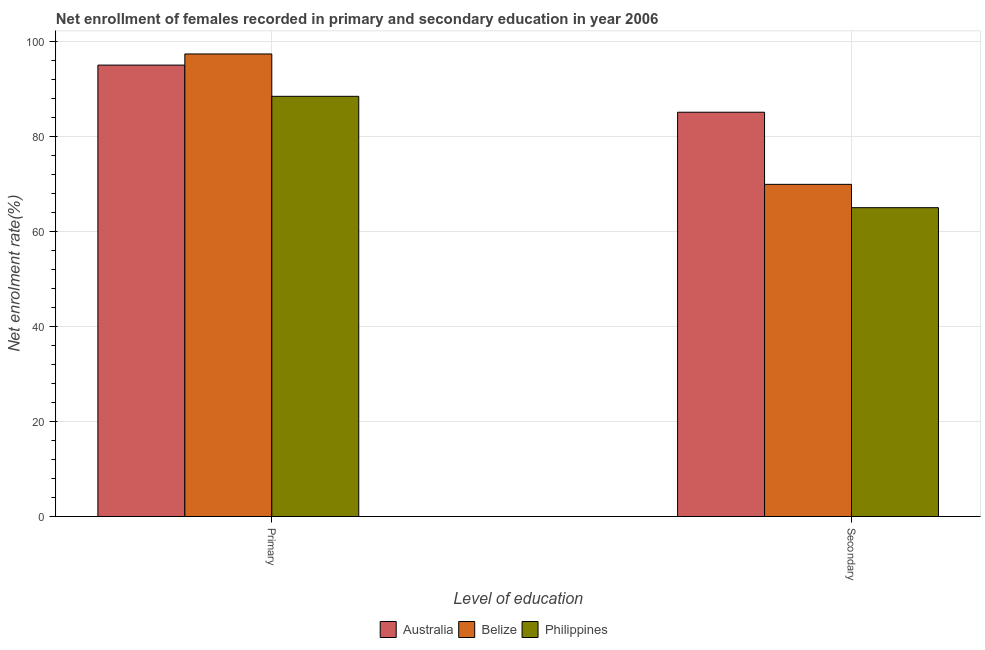How many different coloured bars are there?
Offer a terse response. 3. How many bars are there on the 1st tick from the right?
Provide a succinct answer. 3. What is the label of the 1st group of bars from the left?
Ensure brevity in your answer.  Primary. What is the enrollment rate in secondary education in Australia?
Keep it short and to the point. 85.03. Across all countries, what is the maximum enrollment rate in primary education?
Offer a terse response. 97.29. Across all countries, what is the minimum enrollment rate in primary education?
Offer a very short reply. 88.38. In which country was the enrollment rate in secondary education maximum?
Offer a very short reply. Australia. What is the total enrollment rate in secondary education in the graph?
Ensure brevity in your answer.  219.86. What is the difference between the enrollment rate in primary education in Australia and that in Philippines?
Your response must be concise. 6.57. What is the difference between the enrollment rate in primary education in Australia and the enrollment rate in secondary education in Philippines?
Ensure brevity in your answer.  29.99. What is the average enrollment rate in secondary education per country?
Make the answer very short. 73.29. What is the difference between the enrollment rate in secondary education and enrollment rate in primary education in Belize?
Offer a very short reply. -27.43. In how many countries, is the enrollment rate in secondary education greater than 28 %?
Your response must be concise. 3. What is the ratio of the enrollment rate in primary education in Philippines to that in Australia?
Offer a terse response. 0.93. Is the enrollment rate in primary education in Belize less than that in Australia?
Provide a succinct answer. No. In how many countries, is the enrollment rate in primary education greater than the average enrollment rate in primary education taken over all countries?
Your answer should be very brief. 2. What does the 2nd bar from the left in Primary represents?
Provide a succinct answer. Belize. How many bars are there?
Keep it short and to the point. 6. Are the values on the major ticks of Y-axis written in scientific E-notation?
Keep it short and to the point. No. Does the graph contain grids?
Provide a succinct answer. Yes. How many legend labels are there?
Ensure brevity in your answer.  3. How are the legend labels stacked?
Provide a short and direct response. Horizontal. What is the title of the graph?
Make the answer very short. Net enrollment of females recorded in primary and secondary education in year 2006. What is the label or title of the X-axis?
Your answer should be very brief. Level of education. What is the label or title of the Y-axis?
Make the answer very short. Net enrolment rate(%). What is the Net enrolment rate(%) in Australia in Primary?
Your answer should be very brief. 94.95. What is the Net enrolment rate(%) of Belize in Primary?
Provide a short and direct response. 97.29. What is the Net enrolment rate(%) in Philippines in Primary?
Offer a very short reply. 88.38. What is the Net enrolment rate(%) in Australia in Secondary?
Provide a succinct answer. 85.03. What is the Net enrolment rate(%) of Belize in Secondary?
Your answer should be compact. 69.87. What is the Net enrolment rate(%) of Philippines in Secondary?
Give a very brief answer. 64.96. Across all Level of education, what is the maximum Net enrolment rate(%) in Australia?
Your response must be concise. 94.95. Across all Level of education, what is the maximum Net enrolment rate(%) of Belize?
Your answer should be very brief. 97.29. Across all Level of education, what is the maximum Net enrolment rate(%) in Philippines?
Make the answer very short. 88.38. Across all Level of education, what is the minimum Net enrolment rate(%) of Australia?
Ensure brevity in your answer.  85.03. Across all Level of education, what is the minimum Net enrolment rate(%) of Belize?
Ensure brevity in your answer.  69.87. Across all Level of education, what is the minimum Net enrolment rate(%) of Philippines?
Make the answer very short. 64.96. What is the total Net enrolment rate(%) of Australia in the graph?
Your answer should be compact. 179.98. What is the total Net enrolment rate(%) in Belize in the graph?
Offer a terse response. 167.16. What is the total Net enrolment rate(%) of Philippines in the graph?
Your answer should be very brief. 153.34. What is the difference between the Net enrolment rate(%) in Australia in Primary and that in Secondary?
Make the answer very short. 9.91. What is the difference between the Net enrolment rate(%) of Belize in Primary and that in Secondary?
Provide a succinct answer. 27.43. What is the difference between the Net enrolment rate(%) in Philippines in Primary and that in Secondary?
Offer a terse response. 23.42. What is the difference between the Net enrolment rate(%) in Australia in Primary and the Net enrolment rate(%) in Belize in Secondary?
Ensure brevity in your answer.  25.08. What is the difference between the Net enrolment rate(%) in Australia in Primary and the Net enrolment rate(%) in Philippines in Secondary?
Give a very brief answer. 29.99. What is the difference between the Net enrolment rate(%) of Belize in Primary and the Net enrolment rate(%) of Philippines in Secondary?
Keep it short and to the point. 32.33. What is the average Net enrolment rate(%) of Australia per Level of education?
Give a very brief answer. 89.99. What is the average Net enrolment rate(%) in Belize per Level of education?
Give a very brief answer. 83.58. What is the average Net enrolment rate(%) in Philippines per Level of education?
Make the answer very short. 76.67. What is the difference between the Net enrolment rate(%) in Australia and Net enrolment rate(%) in Belize in Primary?
Ensure brevity in your answer.  -2.34. What is the difference between the Net enrolment rate(%) in Australia and Net enrolment rate(%) in Philippines in Primary?
Your answer should be very brief. 6.57. What is the difference between the Net enrolment rate(%) of Belize and Net enrolment rate(%) of Philippines in Primary?
Give a very brief answer. 8.91. What is the difference between the Net enrolment rate(%) of Australia and Net enrolment rate(%) of Belize in Secondary?
Offer a very short reply. 15.17. What is the difference between the Net enrolment rate(%) in Australia and Net enrolment rate(%) in Philippines in Secondary?
Your answer should be compact. 20.08. What is the difference between the Net enrolment rate(%) in Belize and Net enrolment rate(%) in Philippines in Secondary?
Keep it short and to the point. 4.91. What is the ratio of the Net enrolment rate(%) in Australia in Primary to that in Secondary?
Ensure brevity in your answer.  1.12. What is the ratio of the Net enrolment rate(%) of Belize in Primary to that in Secondary?
Offer a terse response. 1.39. What is the ratio of the Net enrolment rate(%) of Philippines in Primary to that in Secondary?
Make the answer very short. 1.36. What is the difference between the highest and the second highest Net enrolment rate(%) of Australia?
Your response must be concise. 9.91. What is the difference between the highest and the second highest Net enrolment rate(%) of Belize?
Offer a terse response. 27.43. What is the difference between the highest and the second highest Net enrolment rate(%) of Philippines?
Your answer should be very brief. 23.42. What is the difference between the highest and the lowest Net enrolment rate(%) in Australia?
Offer a terse response. 9.91. What is the difference between the highest and the lowest Net enrolment rate(%) in Belize?
Your answer should be compact. 27.43. What is the difference between the highest and the lowest Net enrolment rate(%) in Philippines?
Your answer should be very brief. 23.42. 